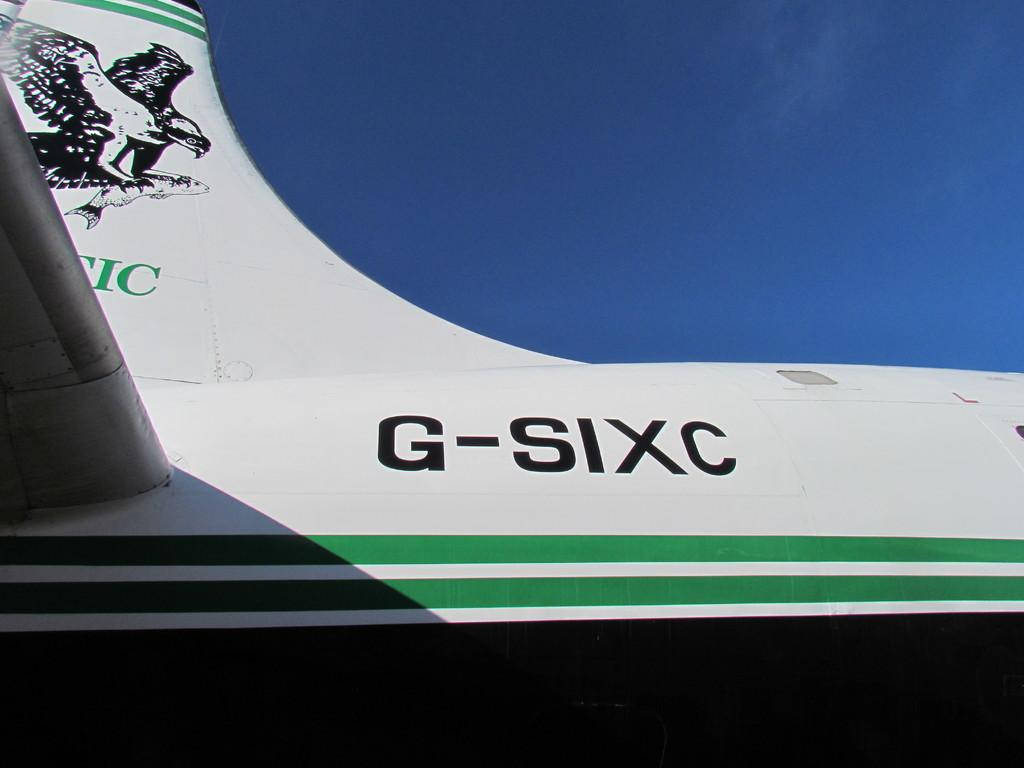<image>
Summarize the visual content of the image. a close up of G-SIXC near the tail end of a white airplane 